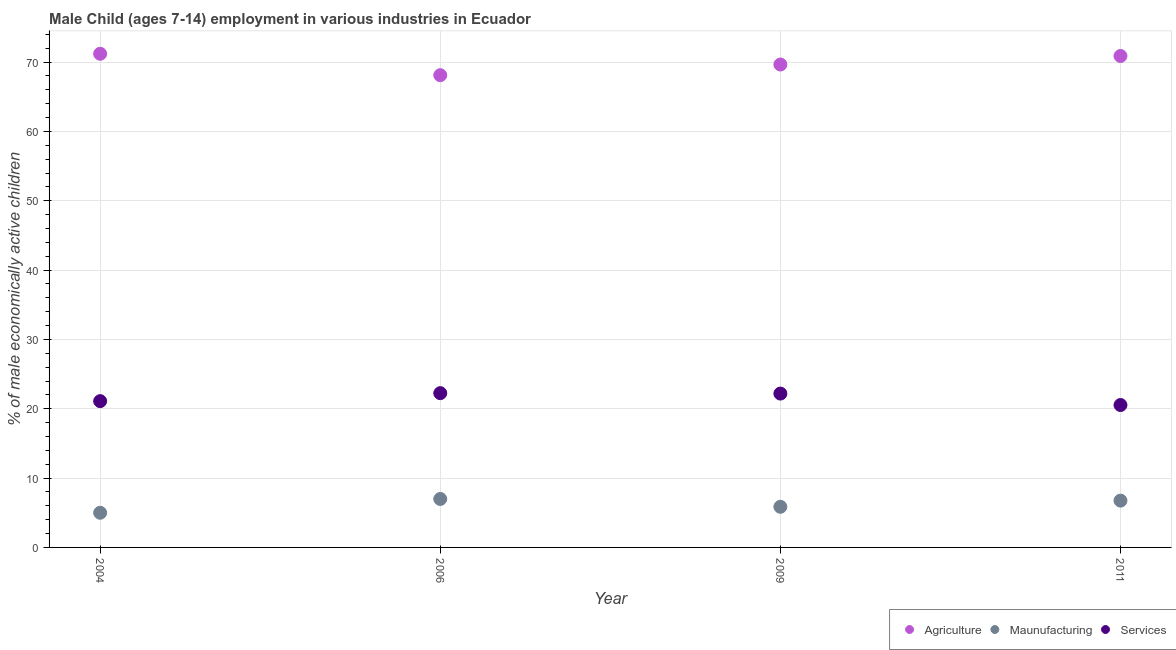What is the percentage of economically active children in agriculture in 2006?
Provide a short and direct response. 68.11. Across all years, what is the maximum percentage of economically active children in services?
Provide a succinct answer. 22.25. Across all years, what is the minimum percentage of economically active children in agriculture?
Make the answer very short. 68.11. In which year was the percentage of economically active children in agriculture maximum?
Offer a terse response. 2004. What is the total percentage of economically active children in services in the graph?
Provide a short and direct response. 86.08. What is the difference between the percentage of economically active children in manufacturing in 2006 and that in 2011?
Offer a terse response. 0.24. What is the difference between the percentage of economically active children in services in 2006 and the percentage of economically active children in agriculture in 2004?
Give a very brief answer. -48.95. What is the average percentage of economically active children in services per year?
Provide a short and direct response. 21.52. In the year 2011, what is the difference between the percentage of economically active children in services and percentage of economically active children in manufacturing?
Offer a terse response. 13.79. What is the ratio of the percentage of economically active children in manufacturing in 2006 to that in 2011?
Provide a succinct answer. 1.04. Is the difference between the percentage of economically active children in agriculture in 2009 and 2011 greater than the difference between the percentage of economically active children in services in 2009 and 2011?
Your response must be concise. No. What is the difference between the highest and the second highest percentage of economically active children in services?
Your answer should be compact. 0.06. What is the difference between the highest and the lowest percentage of economically active children in agriculture?
Make the answer very short. 3.09. In how many years, is the percentage of economically active children in agriculture greater than the average percentage of economically active children in agriculture taken over all years?
Offer a very short reply. 2. Is the sum of the percentage of economically active children in services in 2004 and 2009 greater than the maximum percentage of economically active children in manufacturing across all years?
Provide a succinct answer. Yes. Is the percentage of economically active children in services strictly greater than the percentage of economically active children in manufacturing over the years?
Give a very brief answer. Yes. Is the percentage of economically active children in services strictly less than the percentage of economically active children in agriculture over the years?
Your answer should be very brief. Yes. How many dotlines are there?
Provide a short and direct response. 3. How many years are there in the graph?
Provide a succinct answer. 4. Does the graph contain grids?
Provide a short and direct response. Yes. How many legend labels are there?
Your response must be concise. 3. What is the title of the graph?
Offer a terse response. Male Child (ages 7-14) employment in various industries in Ecuador. What is the label or title of the Y-axis?
Provide a short and direct response. % of male economically active children. What is the % of male economically active children in Agriculture in 2004?
Give a very brief answer. 71.2. What is the % of male economically active children of Maunufacturing in 2004?
Your answer should be very brief. 5. What is the % of male economically active children of Services in 2004?
Your answer should be very brief. 21.1. What is the % of male economically active children of Agriculture in 2006?
Ensure brevity in your answer.  68.11. What is the % of male economically active children of Maunufacturing in 2006?
Ensure brevity in your answer.  6.99. What is the % of male economically active children in Services in 2006?
Keep it short and to the point. 22.25. What is the % of male economically active children of Agriculture in 2009?
Your response must be concise. 69.65. What is the % of male economically active children in Maunufacturing in 2009?
Ensure brevity in your answer.  5.86. What is the % of male economically active children in Services in 2009?
Your answer should be compact. 22.19. What is the % of male economically active children of Agriculture in 2011?
Offer a very short reply. 70.88. What is the % of male economically active children in Maunufacturing in 2011?
Your answer should be very brief. 6.75. What is the % of male economically active children in Services in 2011?
Your answer should be very brief. 20.54. Across all years, what is the maximum % of male economically active children of Agriculture?
Give a very brief answer. 71.2. Across all years, what is the maximum % of male economically active children in Maunufacturing?
Provide a short and direct response. 6.99. Across all years, what is the maximum % of male economically active children in Services?
Offer a very short reply. 22.25. Across all years, what is the minimum % of male economically active children of Agriculture?
Give a very brief answer. 68.11. Across all years, what is the minimum % of male economically active children of Maunufacturing?
Ensure brevity in your answer.  5. Across all years, what is the minimum % of male economically active children in Services?
Provide a succinct answer. 20.54. What is the total % of male economically active children in Agriculture in the graph?
Offer a very short reply. 279.84. What is the total % of male economically active children in Maunufacturing in the graph?
Offer a very short reply. 24.6. What is the total % of male economically active children of Services in the graph?
Your answer should be compact. 86.08. What is the difference between the % of male economically active children of Agriculture in 2004 and that in 2006?
Provide a short and direct response. 3.09. What is the difference between the % of male economically active children in Maunufacturing in 2004 and that in 2006?
Your response must be concise. -1.99. What is the difference between the % of male economically active children of Services in 2004 and that in 2006?
Make the answer very short. -1.15. What is the difference between the % of male economically active children in Agriculture in 2004 and that in 2009?
Provide a succinct answer. 1.55. What is the difference between the % of male economically active children in Maunufacturing in 2004 and that in 2009?
Ensure brevity in your answer.  -0.86. What is the difference between the % of male economically active children in Services in 2004 and that in 2009?
Your answer should be compact. -1.09. What is the difference between the % of male economically active children in Agriculture in 2004 and that in 2011?
Offer a very short reply. 0.32. What is the difference between the % of male economically active children of Maunufacturing in 2004 and that in 2011?
Provide a short and direct response. -1.75. What is the difference between the % of male economically active children in Services in 2004 and that in 2011?
Provide a succinct answer. 0.56. What is the difference between the % of male economically active children in Agriculture in 2006 and that in 2009?
Offer a very short reply. -1.54. What is the difference between the % of male economically active children of Maunufacturing in 2006 and that in 2009?
Ensure brevity in your answer.  1.13. What is the difference between the % of male economically active children in Services in 2006 and that in 2009?
Provide a succinct answer. 0.06. What is the difference between the % of male economically active children of Agriculture in 2006 and that in 2011?
Your answer should be compact. -2.77. What is the difference between the % of male economically active children of Maunufacturing in 2006 and that in 2011?
Make the answer very short. 0.24. What is the difference between the % of male economically active children in Services in 2006 and that in 2011?
Give a very brief answer. 1.71. What is the difference between the % of male economically active children of Agriculture in 2009 and that in 2011?
Provide a succinct answer. -1.23. What is the difference between the % of male economically active children in Maunufacturing in 2009 and that in 2011?
Make the answer very short. -0.89. What is the difference between the % of male economically active children of Services in 2009 and that in 2011?
Your answer should be very brief. 1.65. What is the difference between the % of male economically active children of Agriculture in 2004 and the % of male economically active children of Maunufacturing in 2006?
Offer a very short reply. 64.21. What is the difference between the % of male economically active children in Agriculture in 2004 and the % of male economically active children in Services in 2006?
Offer a very short reply. 48.95. What is the difference between the % of male economically active children in Maunufacturing in 2004 and the % of male economically active children in Services in 2006?
Your answer should be compact. -17.25. What is the difference between the % of male economically active children in Agriculture in 2004 and the % of male economically active children in Maunufacturing in 2009?
Your response must be concise. 65.34. What is the difference between the % of male economically active children in Agriculture in 2004 and the % of male economically active children in Services in 2009?
Provide a succinct answer. 49.01. What is the difference between the % of male economically active children of Maunufacturing in 2004 and the % of male economically active children of Services in 2009?
Your answer should be very brief. -17.19. What is the difference between the % of male economically active children of Agriculture in 2004 and the % of male economically active children of Maunufacturing in 2011?
Your answer should be very brief. 64.45. What is the difference between the % of male economically active children in Agriculture in 2004 and the % of male economically active children in Services in 2011?
Give a very brief answer. 50.66. What is the difference between the % of male economically active children of Maunufacturing in 2004 and the % of male economically active children of Services in 2011?
Keep it short and to the point. -15.54. What is the difference between the % of male economically active children in Agriculture in 2006 and the % of male economically active children in Maunufacturing in 2009?
Provide a short and direct response. 62.25. What is the difference between the % of male economically active children of Agriculture in 2006 and the % of male economically active children of Services in 2009?
Keep it short and to the point. 45.92. What is the difference between the % of male economically active children in Maunufacturing in 2006 and the % of male economically active children in Services in 2009?
Give a very brief answer. -15.2. What is the difference between the % of male economically active children in Agriculture in 2006 and the % of male economically active children in Maunufacturing in 2011?
Offer a terse response. 61.36. What is the difference between the % of male economically active children of Agriculture in 2006 and the % of male economically active children of Services in 2011?
Your response must be concise. 47.57. What is the difference between the % of male economically active children of Maunufacturing in 2006 and the % of male economically active children of Services in 2011?
Your response must be concise. -13.55. What is the difference between the % of male economically active children of Agriculture in 2009 and the % of male economically active children of Maunufacturing in 2011?
Your response must be concise. 62.9. What is the difference between the % of male economically active children of Agriculture in 2009 and the % of male economically active children of Services in 2011?
Give a very brief answer. 49.11. What is the difference between the % of male economically active children in Maunufacturing in 2009 and the % of male economically active children in Services in 2011?
Provide a succinct answer. -14.68. What is the average % of male economically active children in Agriculture per year?
Keep it short and to the point. 69.96. What is the average % of male economically active children in Maunufacturing per year?
Provide a short and direct response. 6.15. What is the average % of male economically active children of Services per year?
Your answer should be compact. 21.52. In the year 2004, what is the difference between the % of male economically active children in Agriculture and % of male economically active children in Maunufacturing?
Give a very brief answer. 66.2. In the year 2004, what is the difference between the % of male economically active children in Agriculture and % of male economically active children in Services?
Make the answer very short. 50.1. In the year 2004, what is the difference between the % of male economically active children in Maunufacturing and % of male economically active children in Services?
Offer a very short reply. -16.1. In the year 2006, what is the difference between the % of male economically active children of Agriculture and % of male economically active children of Maunufacturing?
Provide a short and direct response. 61.12. In the year 2006, what is the difference between the % of male economically active children of Agriculture and % of male economically active children of Services?
Provide a short and direct response. 45.86. In the year 2006, what is the difference between the % of male economically active children of Maunufacturing and % of male economically active children of Services?
Give a very brief answer. -15.26. In the year 2009, what is the difference between the % of male economically active children of Agriculture and % of male economically active children of Maunufacturing?
Provide a short and direct response. 63.79. In the year 2009, what is the difference between the % of male economically active children in Agriculture and % of male economically active children in Services?
Provide a short and direct response. 47.46. In the year 2009, what is the difference between the % of male economically active children in Maunufacturing and % of male economically active children in Services?
Make the answer very short. -16.33. In the year 2011, what is the difference between the % of male economically active children in Agriculture and % of male economically active children in Maunufacturing?
Make the answer very short. 64.13. In the year 2011, what is the difference between the % of male economically active children of Agriculture and % of male economically active children of Services?
Provide a short and direct response. 50.34. In the year 2011, what is the difference between the % of male economically active children in Maunufacturing and % of male economically active children in Services?
Offer a very short reply. -13.79. What is the ratio of the % of male economically active children of Agriculture in 2004 to that in 2006?
Your answer should be very brief. 1.05. What is the ratio of the % of male economically active children in Maunufacturing in 2004 to that in 2006?
Your answer should be very brief. 0.72. What is the ratio of the % of male economically active children of Services in 2004 to that in 2006?
Ensure brevity in your answer.  0.95. What is the ratio of the % of male economically active children of Agriculture in 2004 to that in 2009?
Provide a succinct answer. 1.02. What is the ratio of the % of male economically active children of Maunufacturing in 2004 to that in 2009?
Offer a terse response. 0.85. What is the ratio of the % of male economically active children in Services in 2004 to that in 2009?
Ensure brevity in your answer.  0.95. What is the ratio of the % of male economically active children of Agriculture in 2004 to that in 2011?
Ensure brevity in your answer.  1. What is the ratio of the % of male economically active children of Maunufacturing in 2004 to that in 2011?
Your answer should be very brief. 0.74. What is the ratio of the % of male economically active children of Services in 2004 to that in 2011?
Provide a short and direct response. 1.03. What is the ratio of the % of male economically active children in Agriculture in 2006 to that in 2009?
Offer a very short reply. 0.98. What is the ratio of the % of male economically active children in Maunufacturing in 2006 to that in 2009?
Offer a terse response. 1.19. What is the ratio of the % of male economically active children of Agriculture in 2006 to that in 2011?
Ensure brevity in your answer.  0.96. What is the ratio of the % of male economically active children in Maunufacturing in 2006 to that in 2011?
Your answer should be compact. 1.04. What is the ratio of the % of male economically active children of Services in 2006 to that in 2011?
Offer a terse response. 1.08. What is the ratio of the % of male economically active children in Agriculture in 2009 to that in 2011?
Give a very brief answer. 0.98. What is the ratio of the % of male economically active children of Maunufacturing in 2009 to that in 2011?
Your response must be concise. 0.87. What is the ratio of the % of male economically active children of Services in 2009 to that in 2011?
Make the answer very short. 1.08. What is the difference between the highest and the second highest % of male economically active children of Agriculture?
Give a very brief answer. 0.32. What is the difference between the highest and the second highest % of male economically active children of Maunufacturing?
Offer a very short reply. 0.24. What is the difference between the highest and the lowest % of male economically active children in Agriculture?
Offer a very short reply. 3.09. What is the difference between the highest and the lowest % of male economically active children in Maunufacturing?
Make the answer very short. 1.99. What is the difference between the highest and the lowest % of male economically active children of Services?
Your answer should be very brief. 1.71. 